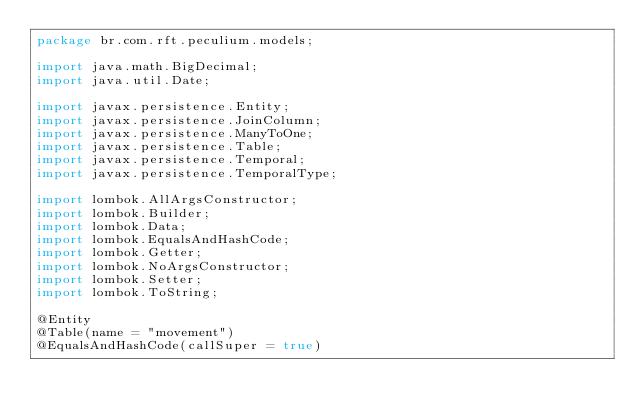<code> <loc_0><loc_0><loc_500><loc_500><_Java_>package br.com.rft.peculium.models;

import java.math.BigDecimal;
import java.util.Date;

import javax.persistence.Entity;
import javax.persistence.JoinColumn;
import javax.persistence.ManyToOne;
import javax.persistence.Table;
import javax.persistence.Temporal;
import javax.persistence.TemporalType;

import lombok.AllArgsConstructor;
import lombok.Builder;
import lombok.Data;
import lombok.EqualsAndHashCode;
import lombok.Getter;
import lombok.NoArgsConstructor;
import lombok.Setter;
import lombok.ToString;

@Entity
@Table(name = "movement")
@EqualsAndHashCode(callSuper = true)</code> 